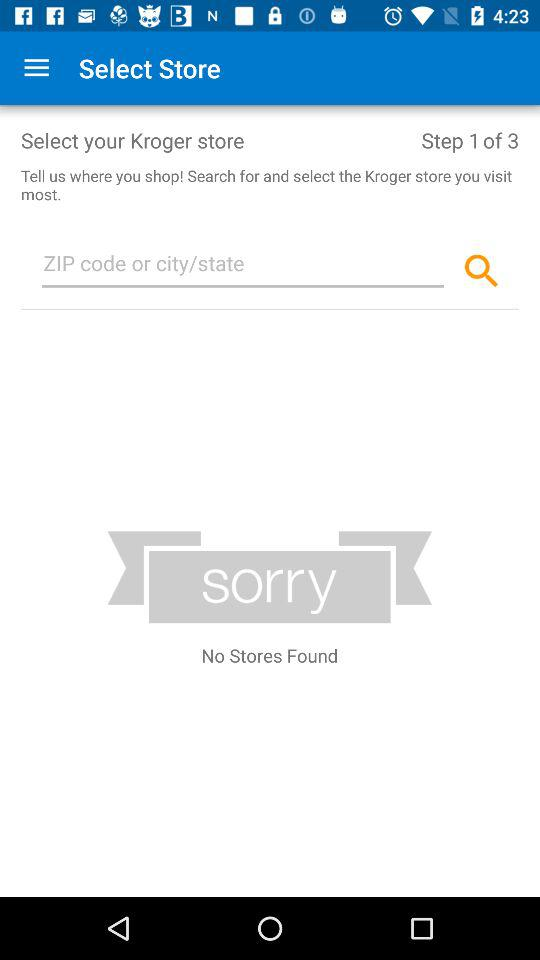How many steps are there in this process?
Answer the question using a single word or phrase. 3 